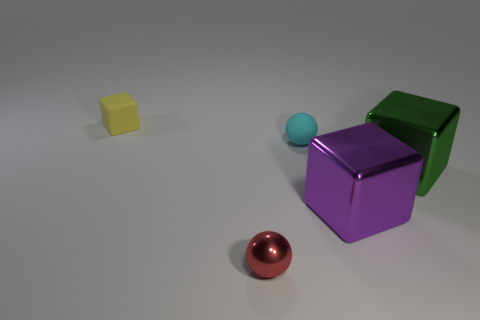Subtract all metallic cubes. How many cubes are left? 1 Add 5 blue matte blocks. How many objects exist? 10 Subtract all purple cubes. How many cubes are left? 2 Subtract all balls. How many objects are left? 3 Subtract 2 balls. How many balls are left? 0 Add 3 tiny cubes. How many tiny cubes are left? 4 Add 5 yellow matte objects. How many yellow matte objects exist? 6 Subtract 0 gray blocks. How many objects are left? 5 Subtract all gray blocks. Subtract all green cylinders. How many blocks are left? 3 Subtract all gray balls. How many purple cubes are left? 1 